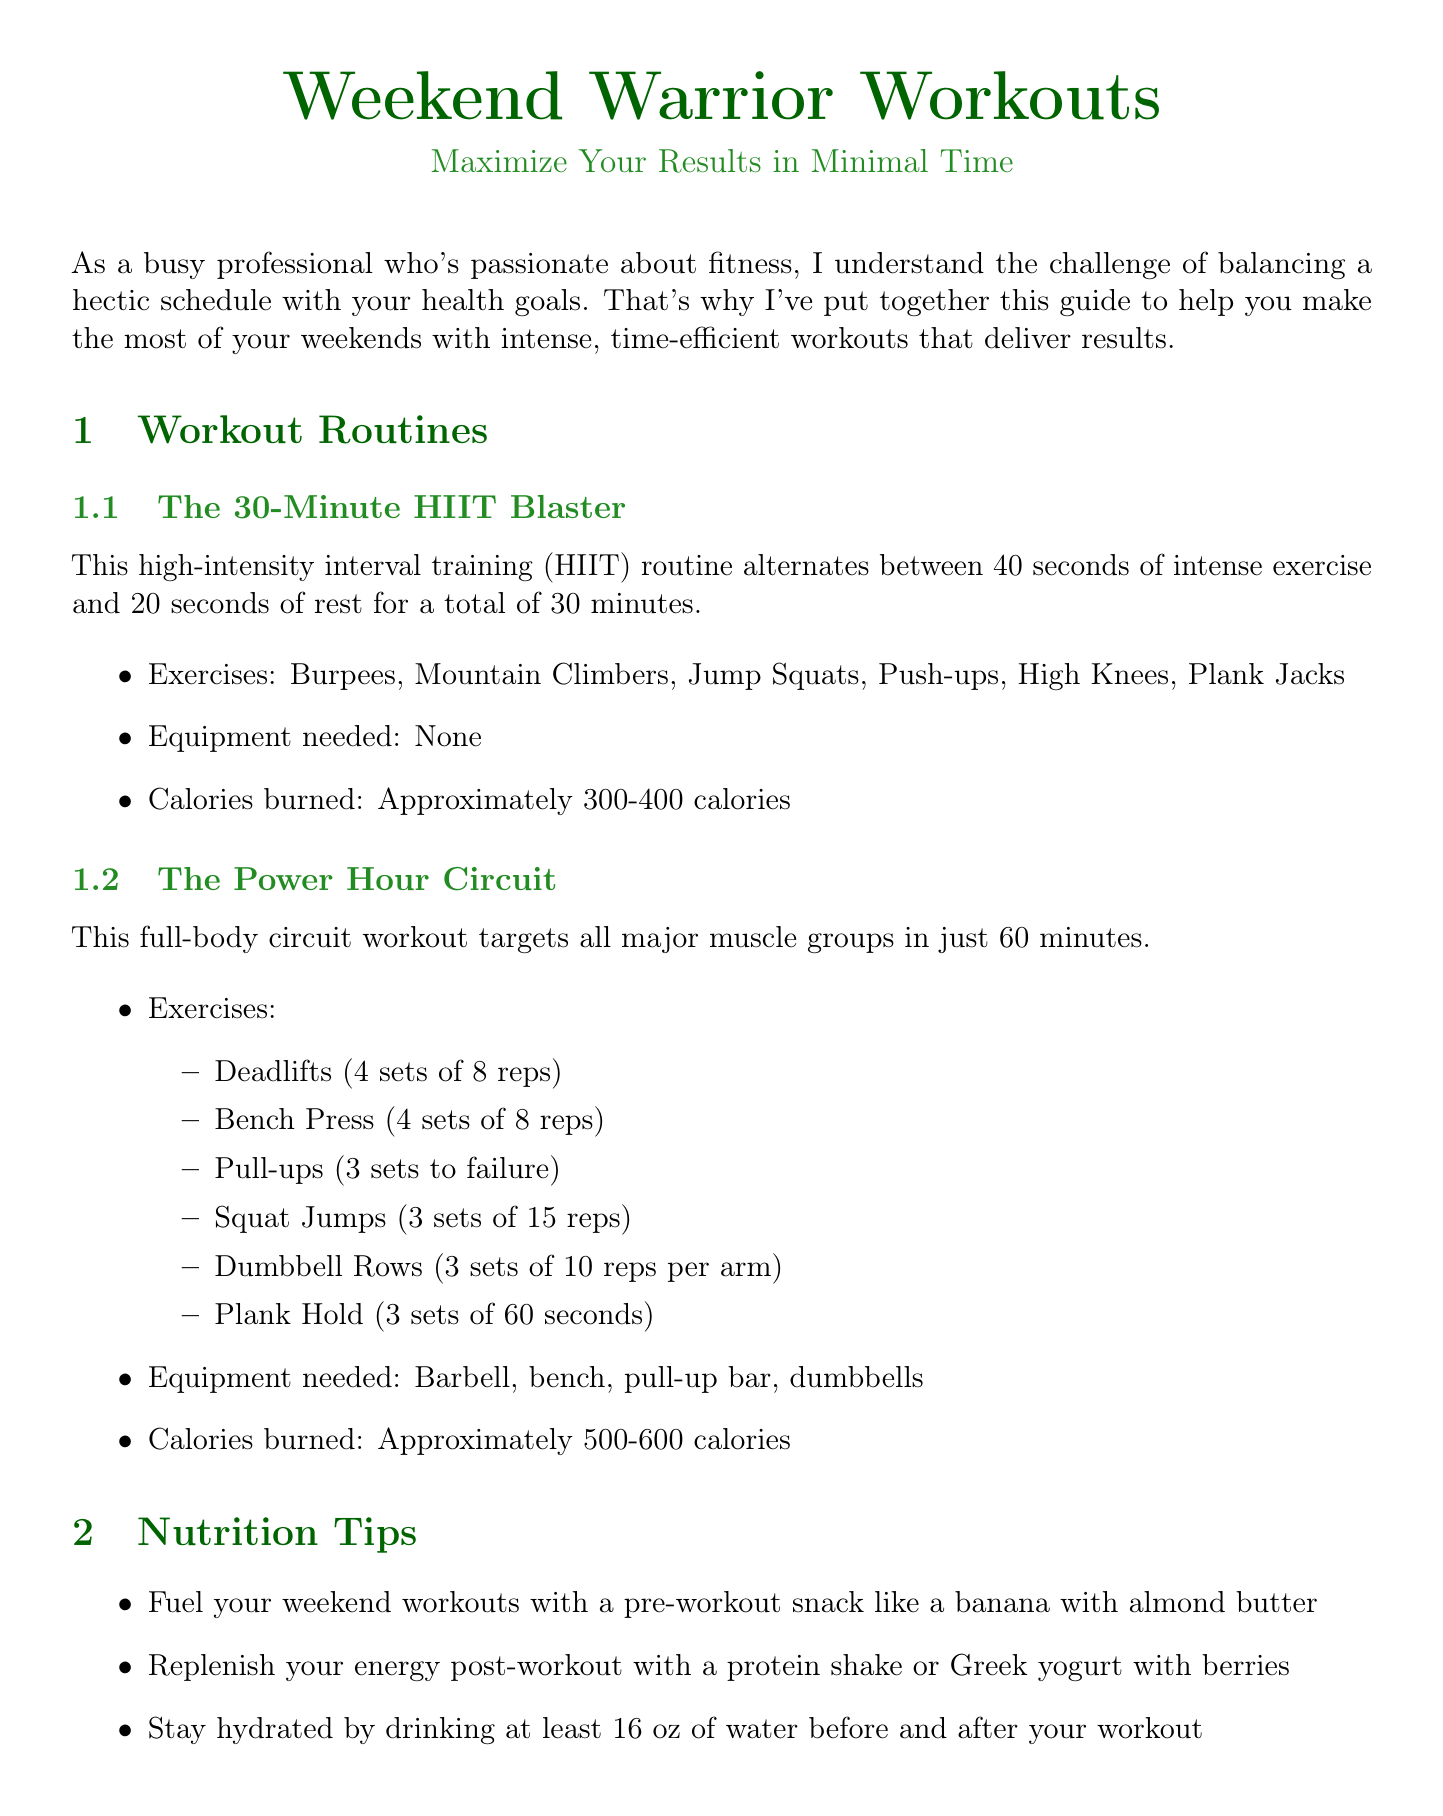What is the title of the newsletter? The title of the newsletter is clearly stated at the beginning of the document.
Answer: Weekend Warrior Workouts: Maximize Your Results in Minimal Time How many calories can you burn with The 30-Minute HIIT Blaster? The calories burned for this workout routine is specified in the workout section of the document.
Answer: Approximately 300-400 calories What type of workout is The Power Hour Circuit? The document categorizes this workout and gives its purpose in the workout routines section.
Answer: Full-body circuit workout Who is Sarah Johnson? This individual is mentioned in the transformation stories section, detailing her background and results from the workouts.
Answer: 32, Marketing Executive What is a recommended post-workout snack? The nutrition tips list one of the suggestions for post-workout recovery.
Answer: Protein shake or Greek yogurt with berries How long did Mike Chen commit to weekend warrior workouts? The transformation stories specify the duration of commitment for Mike Chen.
Answer: 2 months What should you always do before starting high-intensity workouts? Advice from the expert section highlights a crucial pre-workout action.
Answer: Warm up properly Which app offers guided workouts? The recommended apps section lists specific applications and their functionality.
Answer: Nike Training Club 